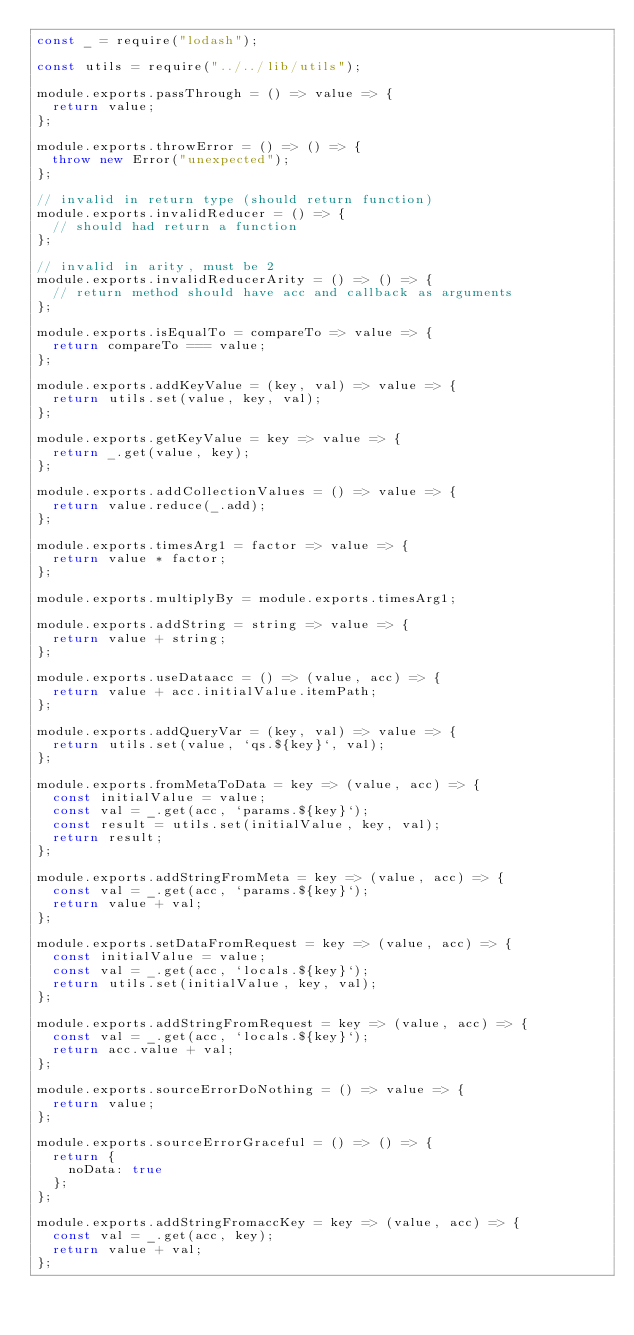Convert code to text. <code><loc_0><loc_0><loc_500><loc_500><_JavaScript_>const _ = require("lodash");

const utils = require("../../lib/utils");

module.exports.passThrough = () => value => {
  return value;
};

module.exports.throwError = () => () => {
  throw new Error("unexpected");
};

// invalid in return type (should return function)
module.exports.invalidReducer = () => {
  // should had return a function
};

// invalid in arity, must be 2
module.exports.invalidReducerArity = () => () => {
  // return method should have acc and callback as arguments
};

module.exports.isEqualTo = compareTo => value => {
  return compareTo === value;
};

module.exports.addKeyValue = (key, val) => value => {
  return utils.set(value, key, val);
};

module.exports.getKeyValue = key => value => {
  return _.get(value, key);
};

module.exports.addCollectionValues = () => value => {
  return value.reduce(_.add);
};

module.exports.timesArg1 = factor => value => {
  return value * factor;
};

module.exports.multiplyBy = module.exports.timesArg1;

module.exports.addString = string => value => {
  return value + string;
};

module.exports.useDataacc = () => (value, acc) => {
  return value + acc.initialValue.itemPath;
};

module.exports.addQueryVar = (key, val) => value => {
  return utils.set(value, `qs.${key}`, val);
};

module.exports.fromMetaToData = key => (value, acc) => {
  const initialValue = value;
  const val = _.get(acc, `params.${key}`);
  const result = utils.set(initialValue, key, val);
  return result;
};

module.exports.addStringFromMeta = key => (value, acc) => {
  const val = _.get(acc, `params.${key}`);
  return value + val;
};

module.exports.setDataFromRequest = key => (value, acc) => {
  const initialValue = value;
  const val = _.get(acc, `locals.${key}`);
  return utils.set(initialValue, key, val);
};

module.exports.addStringFromRequest = key => (value, acc) => {
  const val = _.get(acc, `locals.${key}`);
  return acc.value + val;
};

module.exports.sourceErrorDoNothing = () => value => {
  return value;
};

module.exports.sourceErrorGraceful = () => () => {
  return {
    noData: true
  };
};

module.exports.addStringFromaccKey = key => (value, acc) => {
  const val = _.get(acc, key);
  return value + val;
};
</code> 